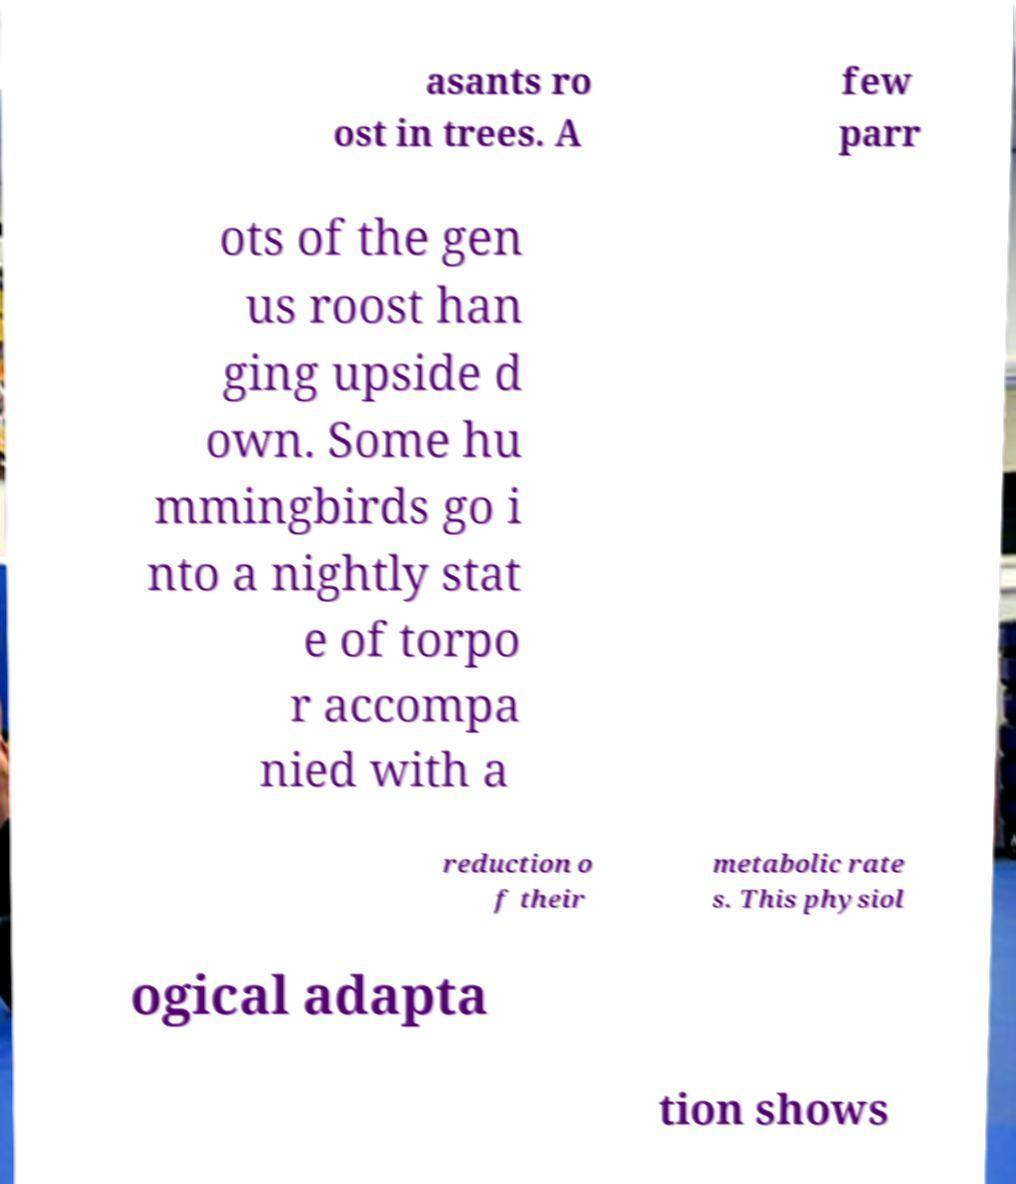For documentation purposes, I need the text within this image transcribed. Could you provide that? asants ro ost in trees. A few parr ots of the gen us roost han ging upside d own. Some hu mmingbirds go i nto a nightly stat e of torpo r accompa nied with a reduction o f their metabolic rate s. This physiol ogical adapta tion shows 